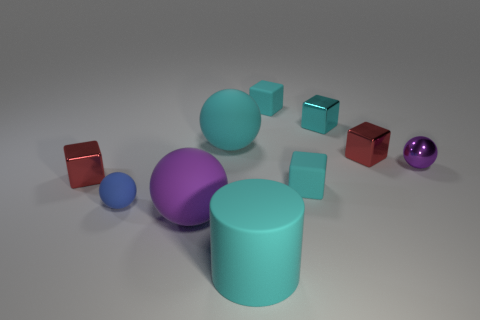There is a blue matte thing that is the same shape as the tiny purple shiny thing; what is its size?
Keep it short and to the point. Small. How many cyan cubes are in front of the tiny rubber object behind the small metal sphere?
Offer a terse response. 2. Do the large cyan thing in front of the purple matte sphere and the big cyan ball on the right side of the tiny blue rubber object have the same material?
Keep it short and to the point. Yes. What number of tiny cyan matte things have the same shape as the tiny purple thing?
Give a very brief answer. 0. What number of cylinders are the same color as the tiny metallic sphere?
Your answer should be very brief. 0. Do the large thing to the left of the large cyan rubber sphere and the large cyan thing to the left of the big cylinder have the same shape?
Make the answer very short. Yes. There is a shiny thing that is to the left of the big sphere behind the large purple matte object; what number of big purple objects are behind it?
Keep it short and to the point. 0. There is a purple ball that is right of the large cyan matte thing to the left of the big matte thing in front of the large purple rubber object; what is its material?
Ensure brevity in your answer.  Metal. Does the big cyan object behind the small matte ball have the same material as the large cyan cylinder?
Provide a short and direct response. Yes. What number of cyan rubber things have the same size as the purple rubber ball?
Keep it short and to the point. 2. 